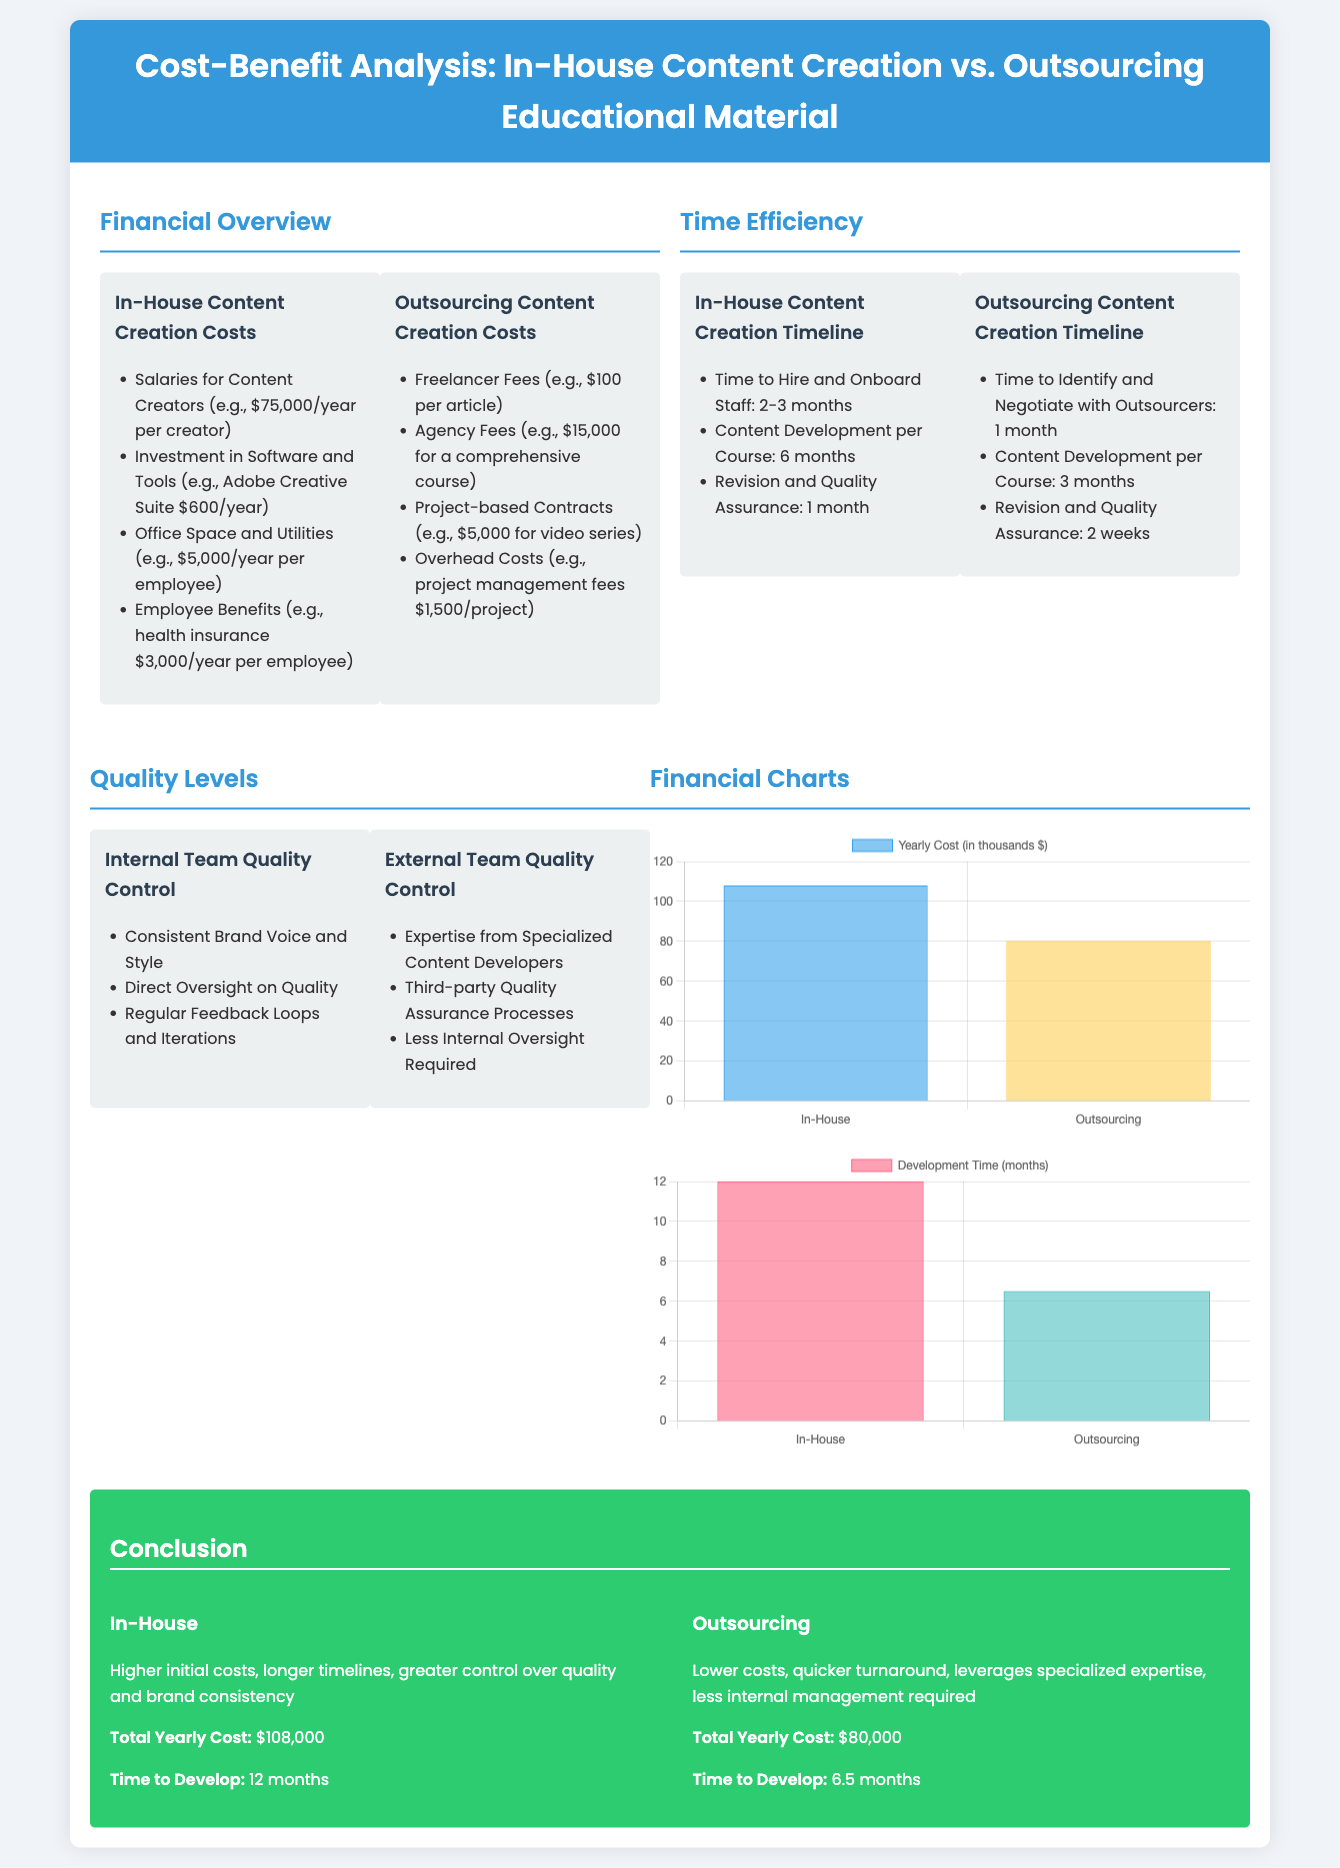What are the yearly costs for in-house content creation? The yearly costs for in-house content creation are detailed in the Financial Overview section, totaling $108,000.
Answer: $108,000 What is the development time for outsourcing content creation? The document states that the development time for outsourcing content creation is 6.5 months, as shown in the Time Efficiency section.
Answer: 6.5 months What are the yearly costs for outsourcing content creation? The yearly costs for outsourcing content creation are provided in the Financial Overview section, which is $80,000.
Answer: $80,000 How long does it take to develop content in-house? According to the Time Efficiency section, the total development time for in-house content creation is 12 months.
Answer: 12 months Which method takes longer to complete the development process? The timeline comparisons between in-house and outsourcing show that in-house takes longer at 12 months versus 6.5 months for outsourcing.
Answer: In-house What is one advantage of in-house quality control? The Quality Levels section mentions the direct oversight on quality as an advantage of in-house quality control.
Answer: Direct oversight on quality What is a disadvantage of outsourcing? The conclusion suggests that outsourcing has less internal oversight required, which is often seen as a disadvantage.
Answer: Less internal oversight What is the sacrifice in opting for lower costs in outsourcing? The conclusion notes that a sacrifice may come in the form of reduced direct control over quality and brand consistency when outsourcing.
Answer: Reduced direct control What is the role of specialized content developers in outsourcing? The document highlights that external teams offer expertise from specialized content developers, as outlined in the Quality Levels section.
Answer: Expertise from specialized content developers 